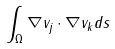Convert formula to latex. <formula><loc_0><loc_0><loc_500><loc_500>\int _ { \Omega } \nabla v _ { j } \cdot \nabla v _ { k } d s</formula> 